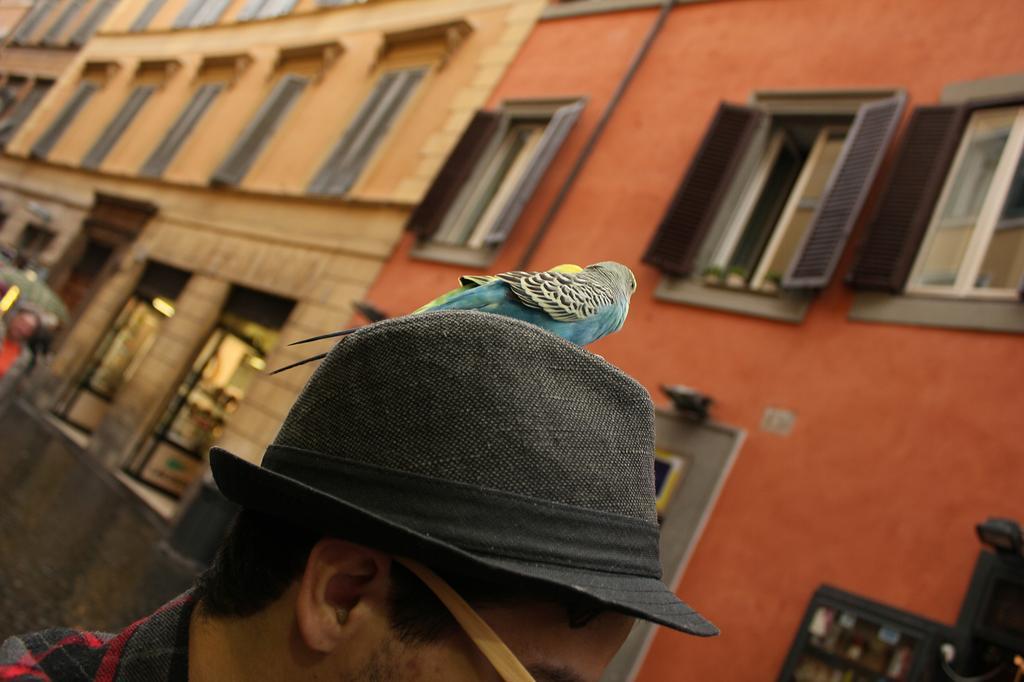Please provide a concise description of this image. In this picture there is a person wore hat and we can see a bird. In the background of the image we can see buildings, windows and person. 